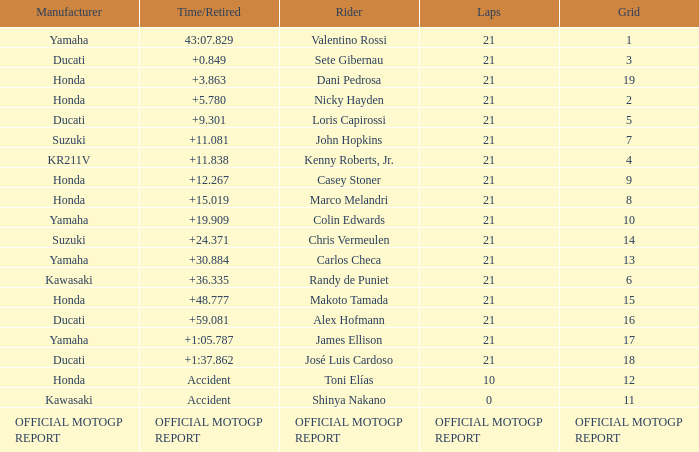What is the time/retired for the rider with the manufacturuer yamaha, grod of 1 and 21 total laps? 43:07.829. Would you be able to parse every entry in this table? {'header': ['Manufacturer', 'Time/Retired', 'Rider', 'Laps', 'Grid'], 'rows': [['Yamaha', '43:07.829', 'Valentino Rossi', '21', '1'], ['Ducati', '+0.849', 'Sete Gibernau', '21', '3'], ['Honda', '+3.863', 'Dani Pedrosa', '21', '19'], ['Honda', '+5.780', 'Nicky Hayden', '21', '2'], ['Ducati', '+9.301', 'Loris Capirossi', '21', '5'], ['Suzuki', '+11.081', 'John Hopkins', '21', '7'], ['KR211V', '+11.838', 'Kenny Roberts, Jr.', '21', '4'], ['Honda', '+12.267', 'Casey Stoner', '21', '9'], ['Honda', '+15.019', 'Marco Melandri', '21', '8'], ['Yamaha', '+19.909', 'Colin Edwards', '21', '10'], ['Suzuki', '+24.371', 'Chris Vermeulen', '21', '14'], ['Yamaha', '+30.884', 'Carlos Checa', '21', '13'], ['Kawasaki', '+36.335', 'Randy de Puniet', '21', '6'], ['Honda', '+48.777', 'Makoto Tamada', '21', '15'], ['Ducati', '+59.081', 'Alex Hofmann', '21', '16'], ['Yamaha', '+1:05.787', 'James Ellison', '21', '17'], ['Ducati', '+1:37.862', 'José Luis Cardoso', '21', '18'], ['Honda', 'Accident', 'Toni Elías', '10', '12'], ['Kawasaki', 'Accident', 'Shinya Nakano', '0', '11'], ['OFFICIAL MOTOGP REPORT', 'OFFICIAL MOTOGP REPORT', 'OFFICIAL MOTOGP REPORT', 'OFFICIAL MOTOGP REPORT', 'OFFICIAL MOTOGP REPORT']]} 